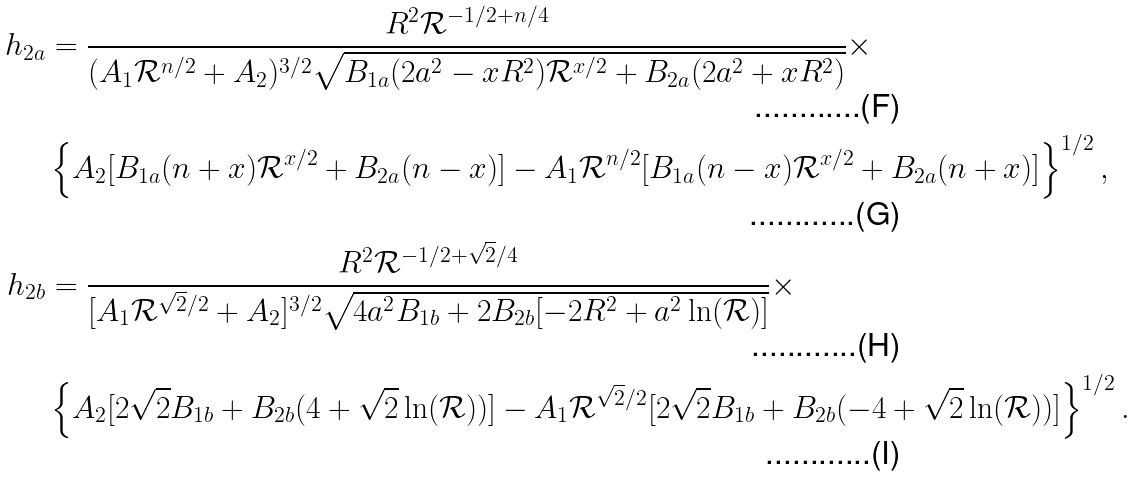<formula> <loc_0><loc_0><loc_500><loc_500>h _ { 2 a } & = \frac { R ^ { 2 } \mathcal { R } ^ { - 1 / 2 + n / 4 } } { ( A _ { 1 } \mathcal { R } ^ { n / 2 } + A _ { 2 } ) ^ { 3 / 2 } \sqrt { B _ { 1 a } ( 2 a ^ { 2 } - x R ^ { 2 } ) \mathcal { R } ^ { x / 2 } + B _ { 2 a } ( 2 a ^ { 2 } + x R ^ { 2 } ) } } \times \\ & \left \{ A _ { 2 } [ B _ { 1 a } ( n + x ) \mathcal { R } ^ { x / 2 } + B _ { 2 a } ( n - x ) ] - A _ { 1 } \mathcal { R } ^ { n / 2 } [ B _ { 1 a } ( n - x ) \mathcal { R } ^ { x / 2 } + B _ { 2 a } ( n + x ) ] \right \} ^ { 1 / 2 } , \\ h _ { 2 b } & = \frac { R ^ { 2 } \mathcal { R } ^ { - 1 / 2 + \sqrt { 2 } / 4 } } { [ A _ { 1 } \mathcal { R } ^ { \sqrt { 2 } / 2 } + A _ { 2 } ] ^ { 3 / 2 } \sqrt { 4 a ^ { 2 } B _ { 1 b } + 2 B _ { 2 b } [ - 2 R ^ { 2 } + a ^ { 2 } \ln ( \mathcal { R } ) ] } } \times \\ & \left \{ A _ { 2 } [ 2 \sqrt { 2 } B _ { 1 b } + B _ { 2 b } ( 4 + \sqrt { 2 } \ln ( \mathcal { R } ) ) ] - A _ { 1 } \mathcal { R } ^ { \sqrt { 2 } / 2 } [ 2 \sqrt { 2 } B _ { 1 b } + B _ { 2 b } ( - 4 + \sqrt { 2 } \ln ( \mathcal { R } ) ) ] \right \} ^ { 1 / 2 } .</formula> 